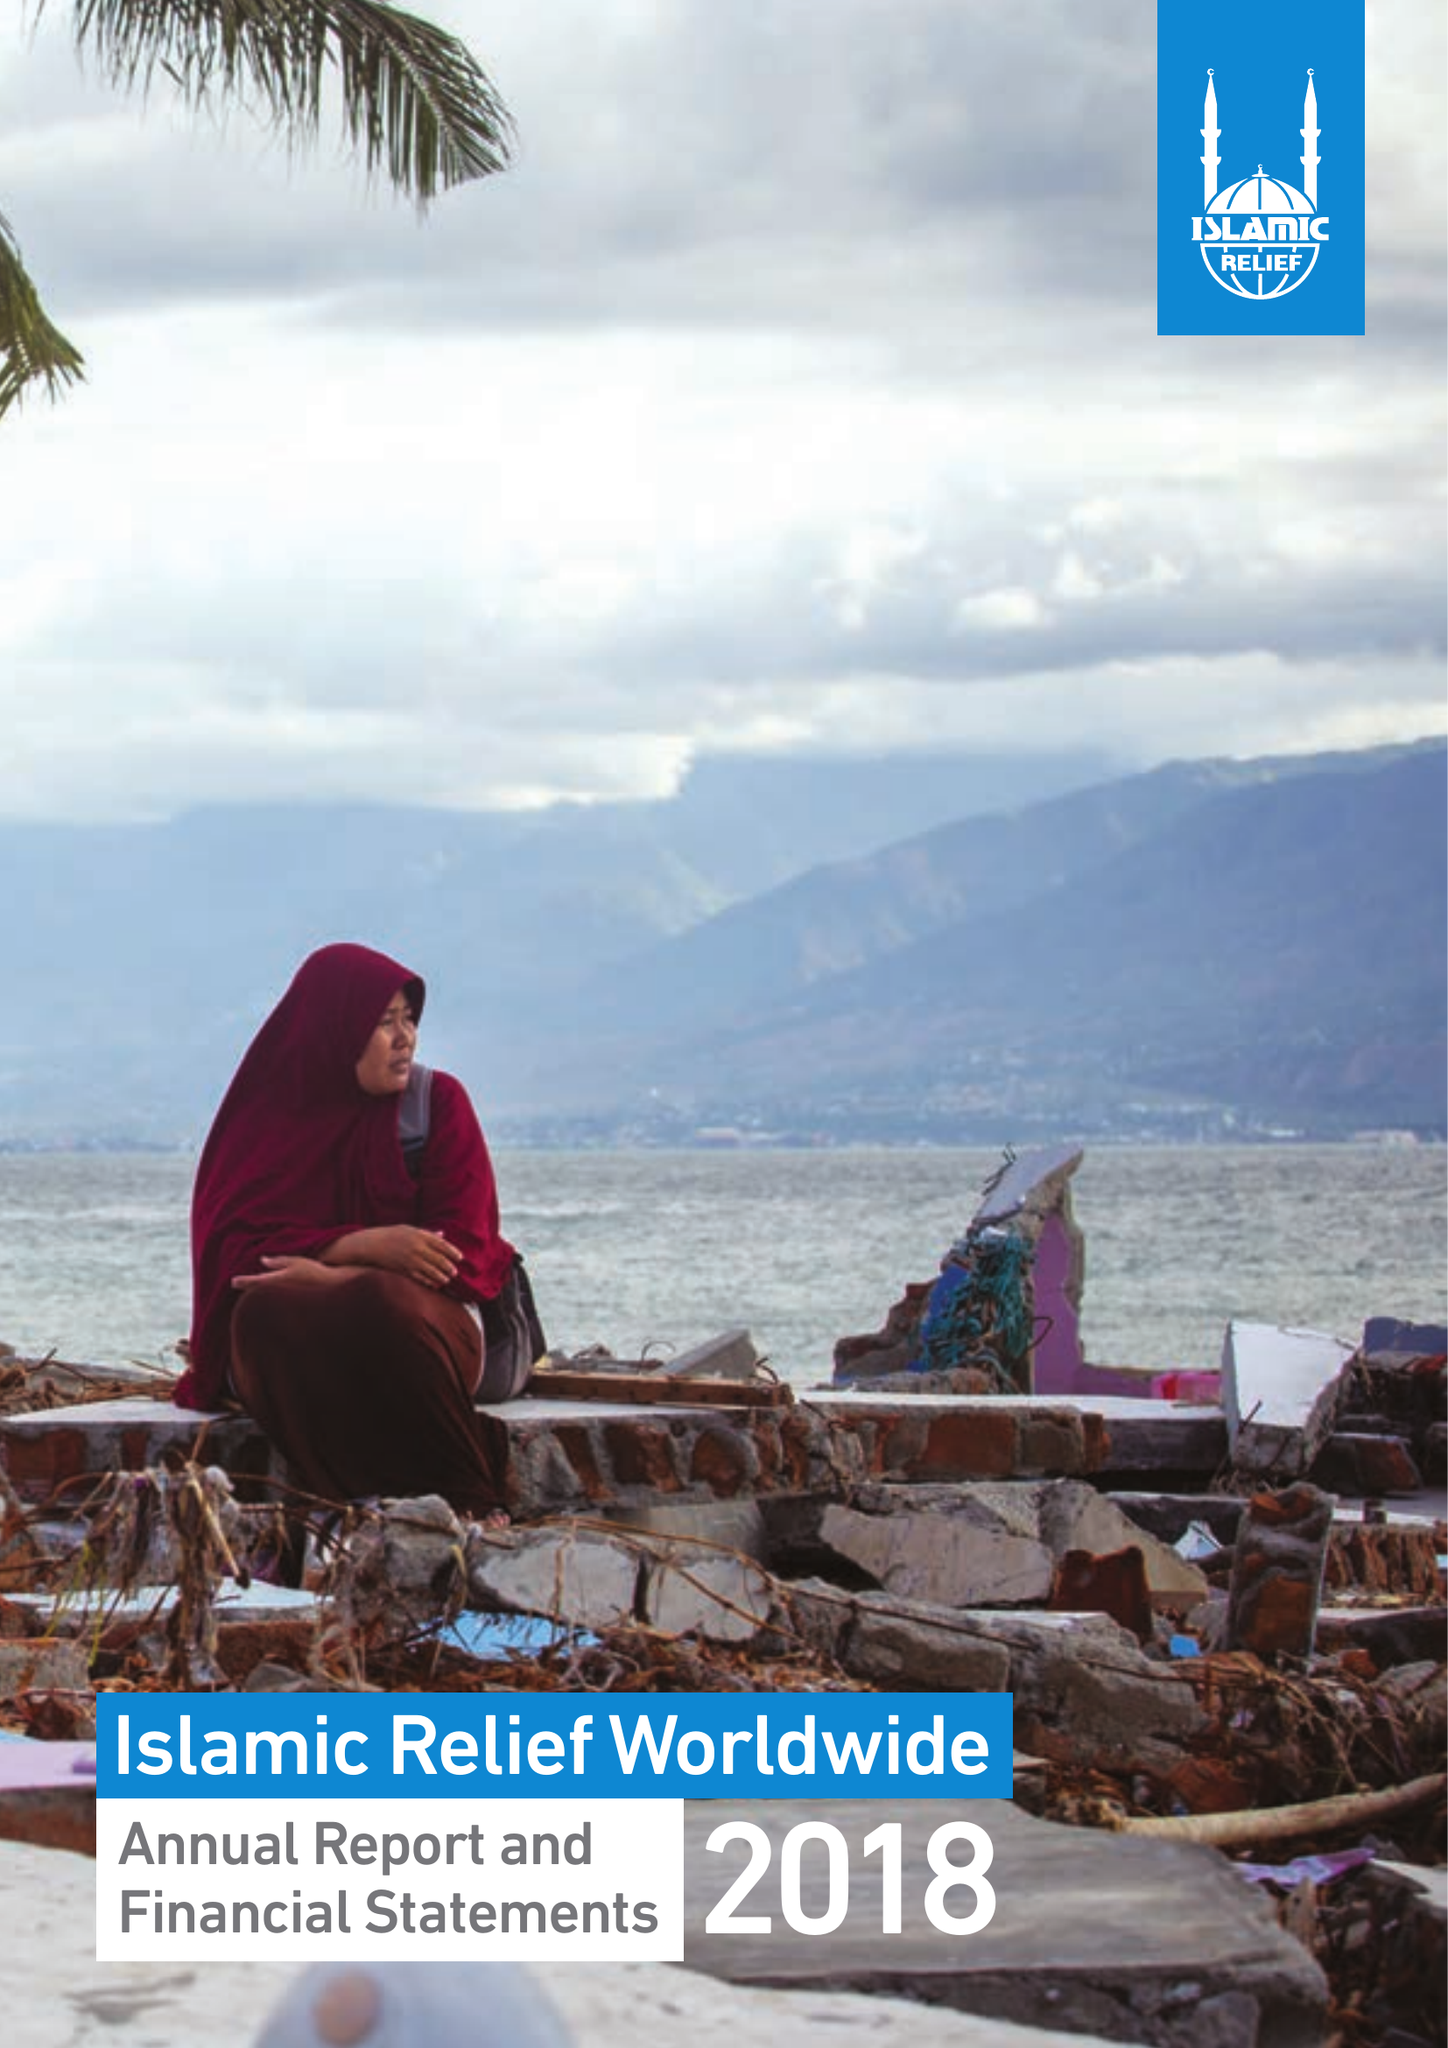What is the value for the address__postcode?
Answer the question using a single word or phrase. B5 6LB 